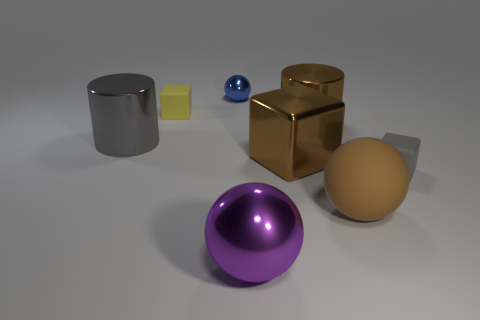There is a tiny rubber thing in front of the large shiny cylinder that is right of the big purple metal thing; what is its color?
Give a very brief answer. Gray. Is the color of the large matte sphere the same as the tiny matte thing that is on the left side of the large brown cube?
Ensure brevity in your answer.  No. There is a object that is both in front of the yellow block and on the left side of the small sphere; what material is it?
Ensure brevity in your answer.  Metal. Is there a blue metal sphere of the same size as the gray metal object?
Offer a very short reply. No. There is a gray cube that is the same size as the blue ball; what is its material?
Provide a short and direct response. Rubber. There is a small yellow rubber thing; how many brown metal cubes are behind it?
Your answer should be very brief. 0. Do the rubber object that is right of the brown ball and the large rubber thing have the same shape?
Offer a very short reply. No. Is there a big green metal thing of the same shape as the big purple thing?
Your response must be concise. No. What material is the cylinder that is the same color as the large cube?
Provide a short and direct response. Metal. The gray thing that is behind the large cube behind the large purple metal thing is what shape?
Your response must be concise. Cylinder. 